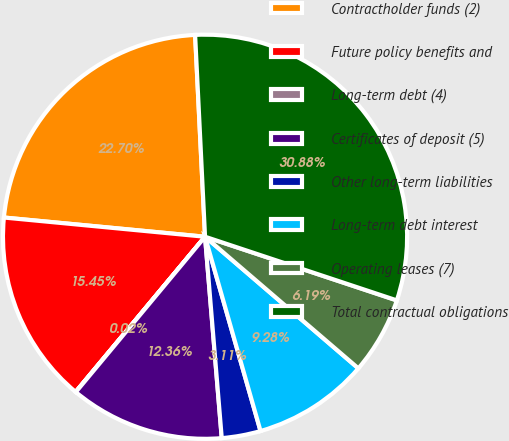Convert chart to OTSL. <chart><loc_0><loc_0><loc_500><loc_500><pie_chart><fcel>Contractholder funds (2)<fcel>Future policy benefits and<fcel>Long-term debt (4)<fcel>Certificates of deposit (5)<fcel>Other long-term liabilities<fcel>Long-term debt interest<fcel>Operating leases (7)<fcel>Total contractual obligations<nl><fcel>22.7%<fcel>15.45%<fcel>0.02%<fcel>12.36%<fcel>3.11%<fcel>9.28%<fcel>6.19%<fcel>30.88%<nl></chart> 